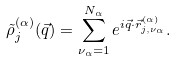<formula> <loc_0><loc_0><loc_500><loc_500>\tilde { \rho } _ { j } ^ { ( \alpha ) } ( \vec { q } ) = \sum _ { \nu _ { \alpha } = 1 } ^ { N _ { \alpha } } e ^ { i \vec { q } \cdot \vec { r } _ { j , \nu _ { \alpha } } ^ { ( \alpha ) } } .</formula> 